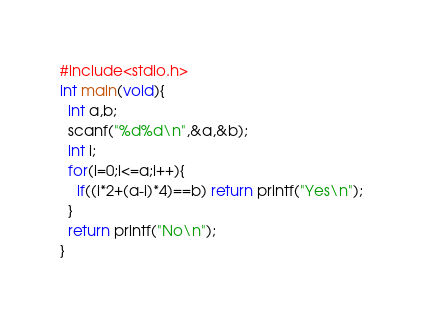<code> <loc_0><loc_0><loc_500><loc_500><_C_>#include<stdio.h>
int main(void){
  int a,b;
  scanf("%d%d\n",&a,&b);
  int i;
  for(i=0;i<=a;i++){
    if((i*2+(a-i)*4)==b) return printf("Yes\n");
  }
  return printf("No\n");
}
</code> 